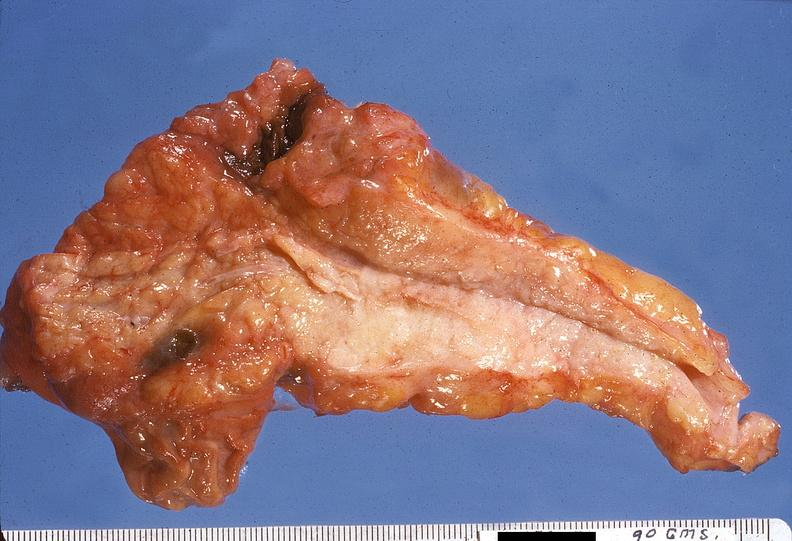does median lobe hyperplasia with marked cystitis and bladder hypertrophy ureter show adenocarcinoma, body of pancreas?
Answer the question using a single word or phrase. No 